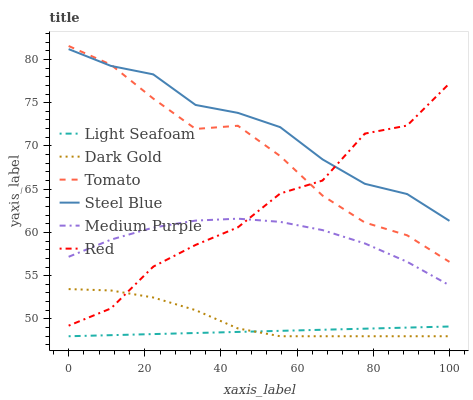Does Light Seafoam have the minimum area under the curve?
Answer yes or no. Yes. Does Steel Blue have the maximum area under the curve?
Answer yes or no. Yes. Does Dark Gold have the minimum area under the curve?
Answer yes or no. No. Does Dark Gold have the maximum area under the curve?
Answer yes or no. No. Is Light Seafoam the smoothest?
Answer yes or no. Yes. Is Red the roughest?
Answer yes or no. Yes. Is Dark Gold the smoothest?
Answer yes or no. No. Is Dark Gold the roughest?
Answer yes or no. No. Does Dark Gold have the lowest value?
Answer yes or no. Yes. Does Steel Blue have the lowest value?
Answer yes or no. No. Does Tomato have the highest value?
Answer yes or no. Yes. Does Dark Gold have the highest value?
Answer yes or no. No. Is Light Seafoam less than Tomato?
Answer yes or no. Yes. Is Steel Blue greater than Light Seafoam?
Answer yes or no. Yes. Does Red intersect Dark Gold?
Answer yes or no. Yes. Is Red less than Dark Gold?
Answer yes or no. No. Is Red greater than Dark Gold?
Answer yes or no. No. Does Light Seafoam intersect Tomato?
Answer yes or no. No. 